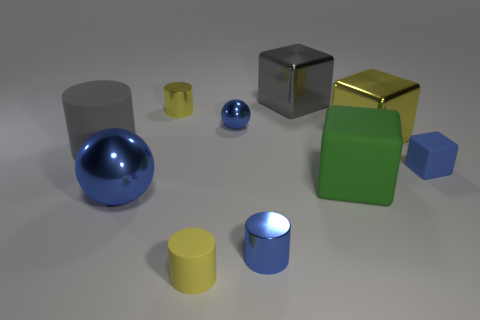Subtract all cylinders. How many objects are left? 6 Subtract 1 blue blocks. How many objects are left? 9 Subtract all red metallic things. Subtract all small yellow cylinders. How many objects are left? 8 Add 5 large blue shiny balls. How many large blue shiny balls are left? 6 Add 10 large brown matte spheres. How many large brown matte spheres exist? 10 